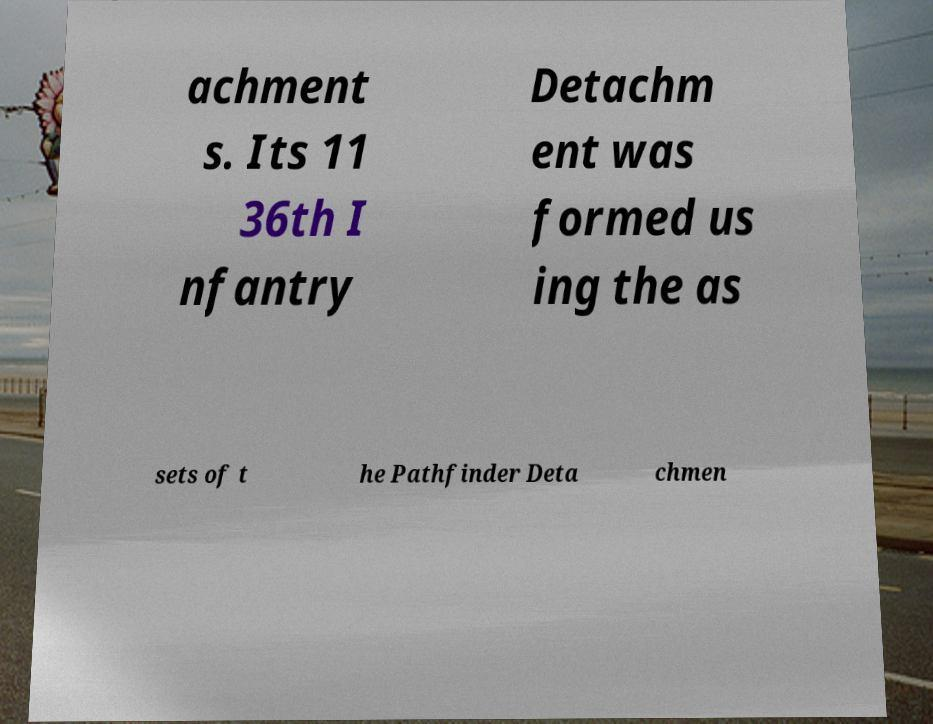Can you read and provide the text displayed in the image?This photo seems to have some interesting text. Can you extract and type it out for me? achment s. Its 11 36th I nfantry Detachm ent was formed us ing the as sets of t he Pathfinder Deta chmen 